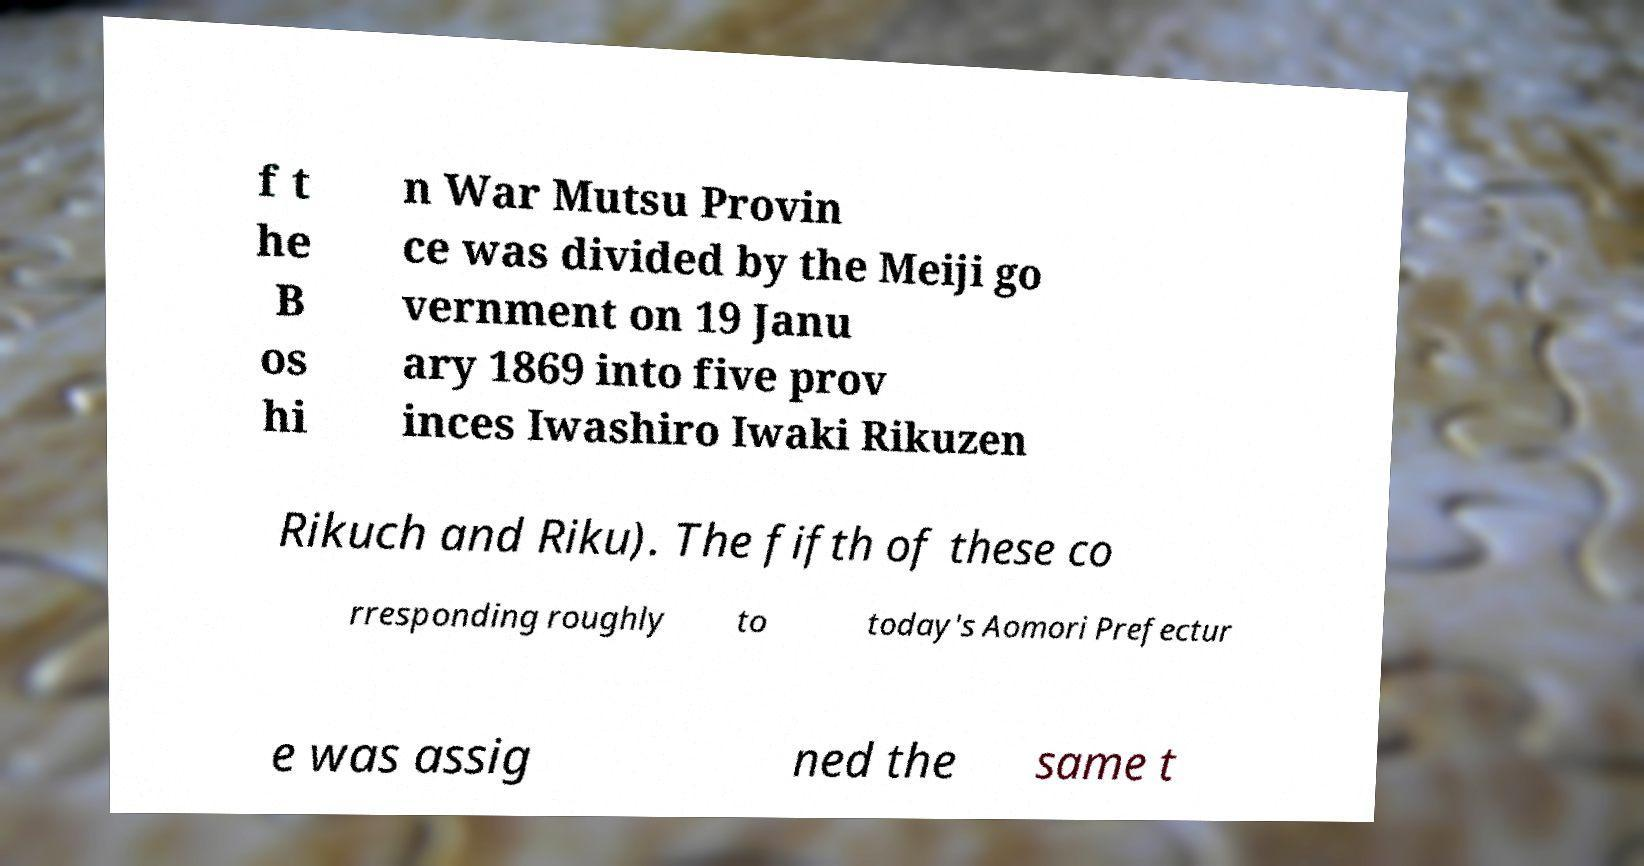Can you read and provide the text displayed in the image?This photo seems to have some interesting text. Can you extract and type it out for me? f t he B os hi n War Mutsu Provin ce was divided by the Meiji go vernment on 19 Janu ary 1869 into five prov inces Iwashiro Iwaki Rikuzen Rikuch and Riku). The fifth of these co rresponding roughly to today's Aomori Prefectur e was assig ned the same t 